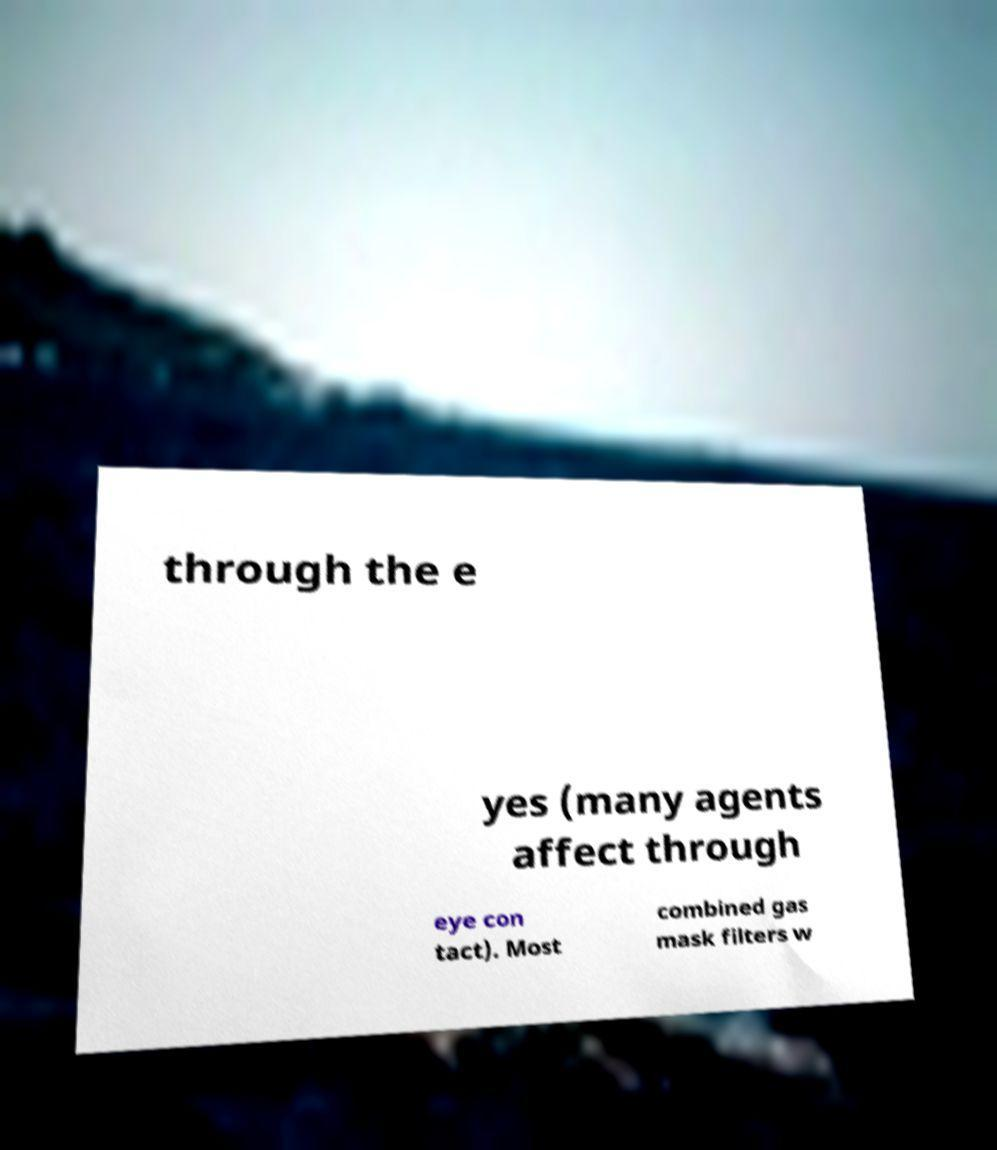Could you assist in decoding the text presented in this image and type it out clearly? through the e yes (many agents affect through eye con tact). Most combined gas mask filters w 